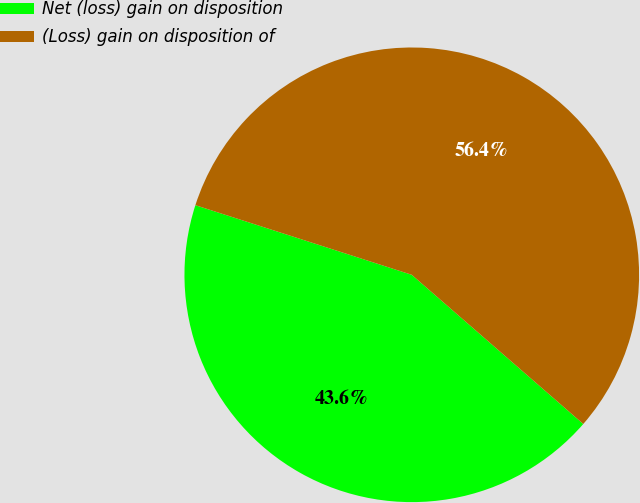Convert chart to OTSL. <chart><loc_0><loc_0><loc_500><loc_500><pie_chart><fcel>Net (loss) gain on disposition<fcel>(Loss) gain on disposition of<nl><fcel>43.56%<fcel>56.44%<nl></chart> 